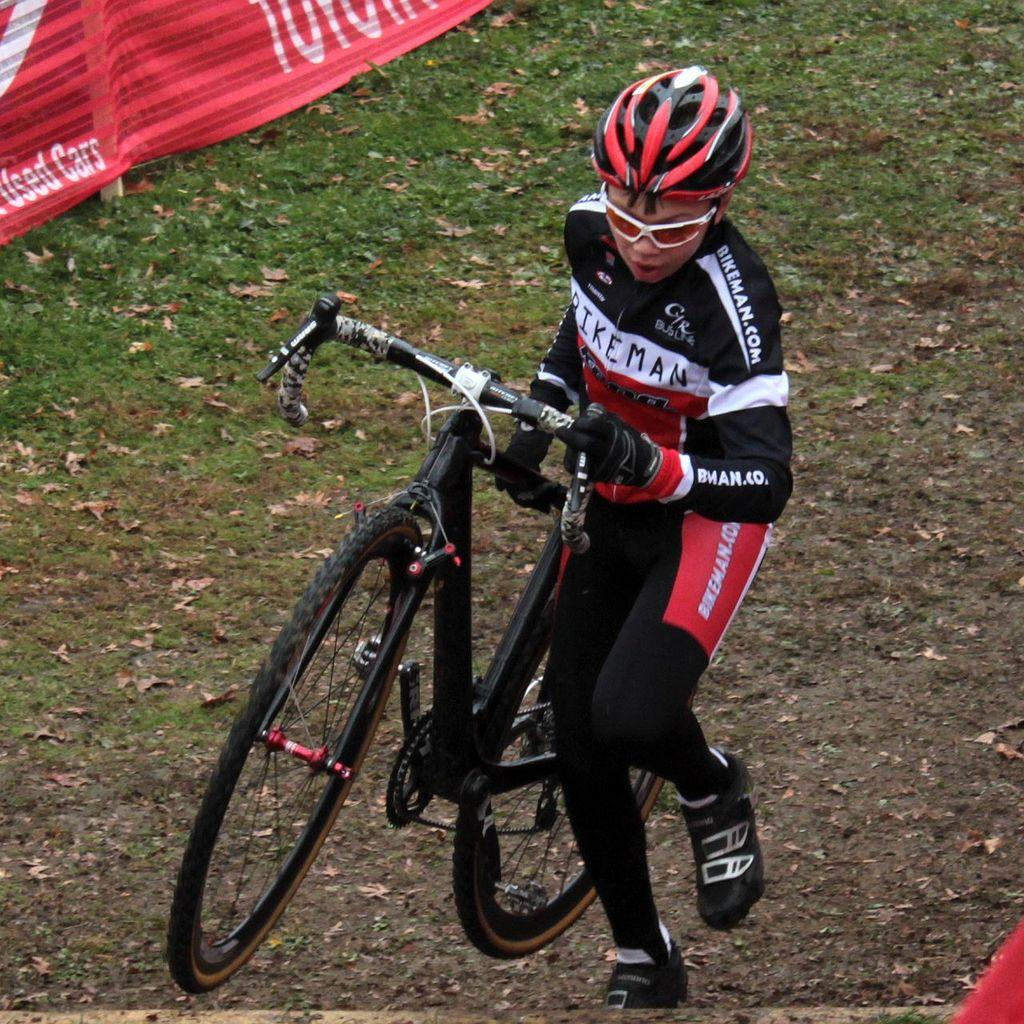What is the person in the image doing? The person is standing in the image and holding a bicycle. What can be seen in the background of the image? There is grass and a red color cloth in the background of the image. What type of crayon is the person using to draw on the bicycle in the image? There is no crayon present in the image, and the person is not drawing on the bicycle. 